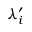Convert formula to latex. <formula><loc_0><loc_0><loc_500><loc_500>\lambda _ { i } ^ { \prime }</formula> 